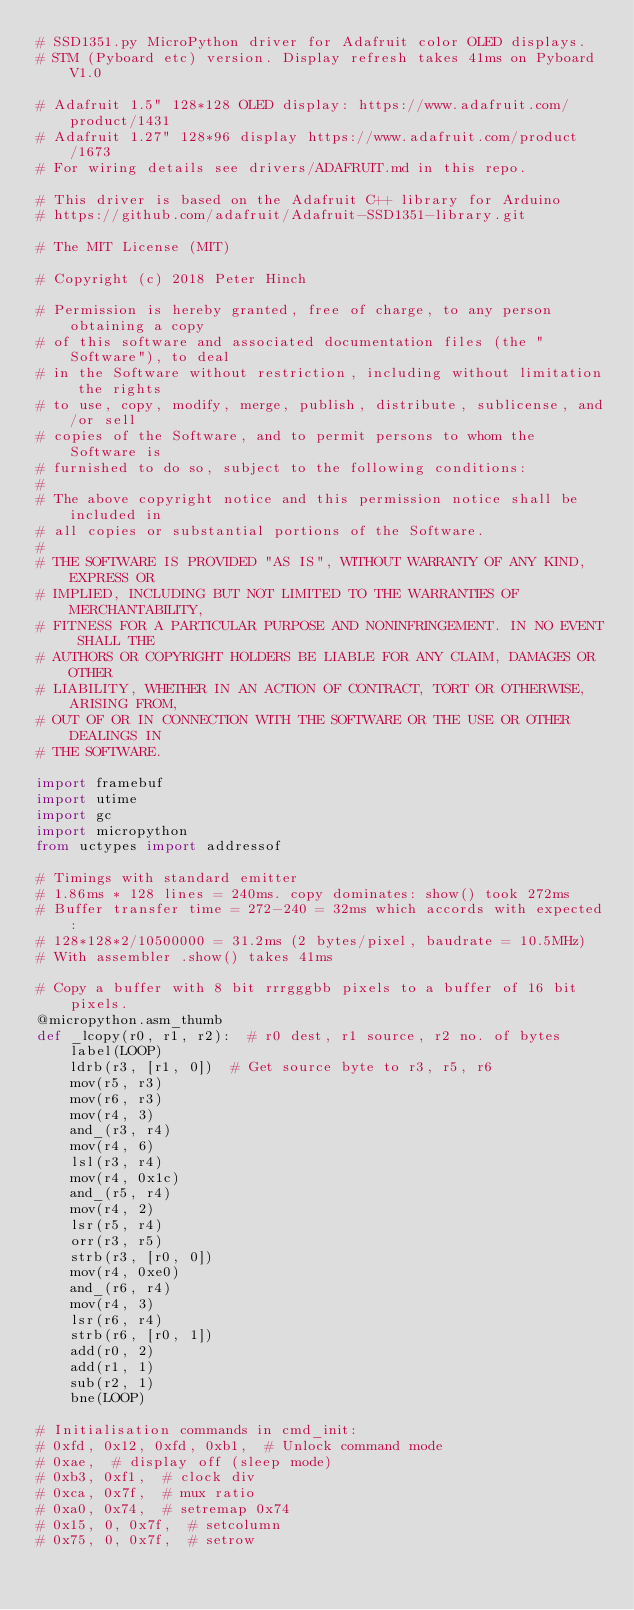<code> <loc_0><loc_0><loc_500><loc_500><_Python_># SSD1351.py MicroPython driver for Adafruit color OLED displays.
# STM (Pyboard etc) version. Display refresh takes 41ms on Pyboard V1.0

# Adafruit 1.5" 128*128 OLED display: https://www.adafruit.com/product/1431
# Adafruit 1.27" 128*96 display https://www.adafruit.com/product/1673
# For wiring details see drivers/ADAFRUIT.md in this repo.

# This driver is based on the Adafruit C++ library for Arduino
# https://github.com/adafruit/Adafruit-SSD1351-library.git

# The MIT License (MIT)

# Copyright (c) 2018 Peter Hinch

# Permission is hereby granted, free of charge, to any person obtaining a copy
# of this software and associated documentation files (the "Software"), to deal
# in the Software without restriction, including without limitation the rights
# to use, copy, modify, merge, publish, distribute, sublicense, and/or sell
# copies of the Software, and to permit persons to whom the Software is
# furnished to do so, subject to the following conditions:
#
# The above copyright notice and this permission notice shall be included in
# all copies or substantial portions of the Software.
#
# THE SOFTWARE IS PROVIDED "AS IS", WITHOUT WARRANTY OF ANY KIND, EXPRESS OR
# IMPLIED, INCLUDING BUT NOT LIMITED TO THE WARRANTIES OF MERCHANTABILITY,
# FITNESS FOR A PARTICULAR PURPOSE AND NONINFRINGEMENT. IN NO EVENT SHALL THE
# AUTHORS OR COPYRIGHT HOLDERS BE LIABLE FOR ANY CLAIM, DAMAGES OR OTHER
# LIABILITY, WHETHER IN AN ACTION OF CONTRACT, TORT OR OTHERWISE, ARISING FROM,
# OUT OF OR IN CONNECTION WITH THE SOFTWARE OR THE USE OR OTHER DEALINGS IN
# THE SOFTWARE.

import framebuf
import utime
import gc
import micropython
from uctypes import addressof

# Timings with standard emitter
# 1.86ms * 128 lines = 240ms. copy dominates: show() took 272ms
# Buffer transfer time = 272-240 = 32ms which accords with expected:
# 128*128*2/10500000 = 31.2ms (2 bytes/pixel, baudrate = 10.5MHz)
# With assembler .show() takes 41ms

# Copy a buffer with 8 bit rrrgggbb pixels to a buffer of 16 bit pixels.
@micropython.asm_thumb
def _lcopy(r0, r1, r2):  # r0 dest, r1 source, r2 no. of bytes
    label(LOOP)
    ldrb(r3, [r1, 0])  # Get source byte to r3, r5, r6
    mov(r5, r3)
    mov(r6, r3)
    mov(r4, 3)
    and_(r3, r4)
    mov(r4, 6)
    lsl(r3, r4)
    mov(r4, 0x1c)
    and_(r5, r4)
    mov(r4, 2)
    lsr(r5, r4)
    orr(r3, r5)
    strb(r3, [r0, 0])
    mov(r4, 0xe0)
    and_(r6, r4)
    mov(r4, 3)
    lsr(r6, r4)
    strb(r6, [r0, 1])
    add(r0, 2)
    add(r1, 1)
    sub(r2, 1)
    bne(LOOP)

# Initialisation commands in cmd_init:
# 0xfd, 0x12, 0xfd, 0xb1,  # Unlock command mode
# 0xae,  # display off (sleep mode)
# 0xb3, 0xf1,  # clock div
# 0xca, 0x7f,  # mux ratio
# 0xa0, 0x74,  # setremap 0x74
# 0x15, 0, 0x7f,  # setcolumn
# 0x75, 0, 0x7f,  # setrow</code> 